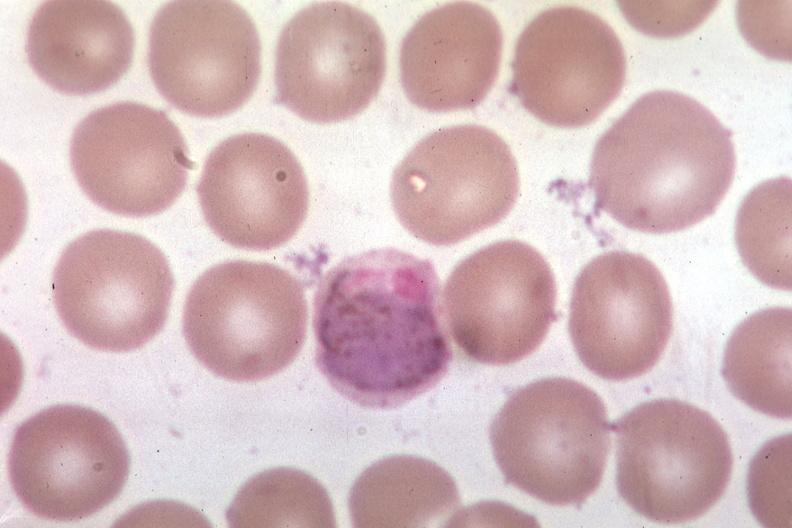what is present?
Answer the question using a single word or phrase. Hematologic 